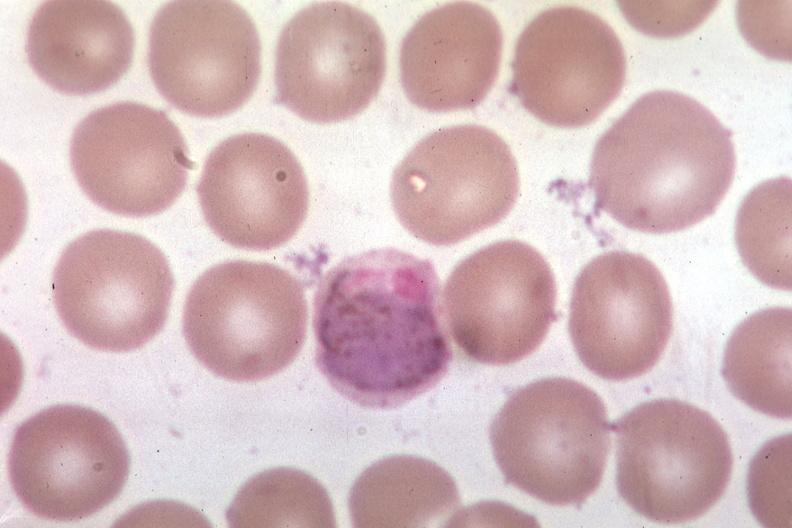what is present?
Answer the question using a single word or phrase. Hematologic 